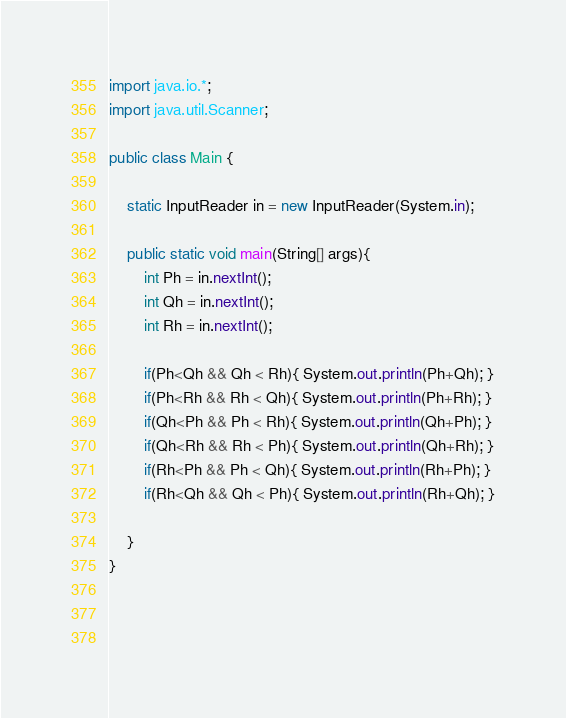Convert code to text. <code><loc_0><loc_0><loc_500><loc_500><_Java_>import java.io.*; 
import java.util.Scanner;

public class Main {
	
	static InputReader in = new InputReader(System.in);

	public static void main(String[] args){
		int Ph = in.nextInt();
      	int Qh = in.nextInt();
      	int Rh = in.nextInt();
      
      	if(Ph<Qh && Qh < Rh){ System.out.println(Ph+Qh); }
        if(Ph<Rh && Rh < Qh){ System.out.println(Ph+Rh); }
      	if(Qh<Ph && Ph < Rh){ System.out.println(Qh+Ph); }
      	if(Qh<Rh && Rh < Ph){ System.out.println(Qh+Rh); }
      	if(Rh<Ph && Ph < Qh){ System.out.println(Rh+Ph); }
      	if(Rh<Qh && Qh < Ph){ System.out.println(Rh+Qh); }
      
	}
}


	
</code> 